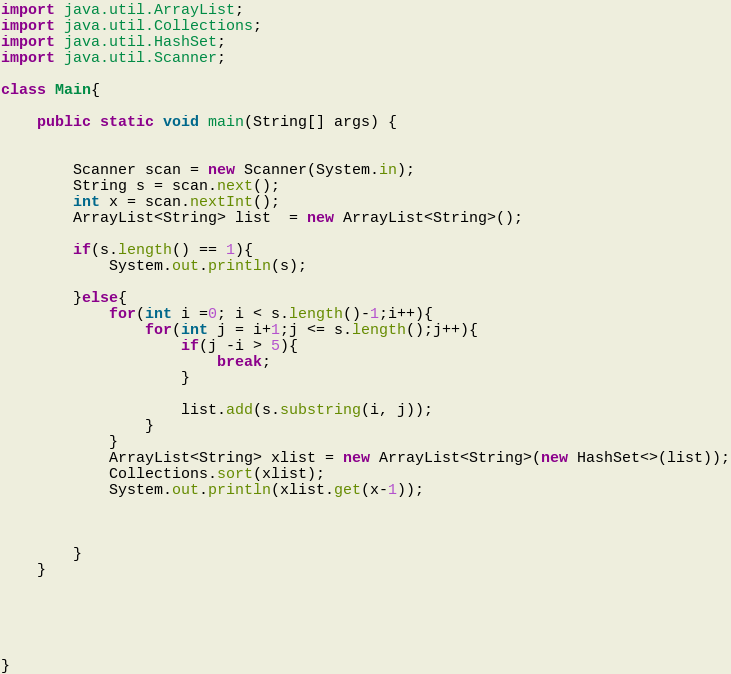<code> <loc_0><loc_0><loc_500><loc_500><_Java_>import java.util.ArrayList;
import java.util.Collections;
import java.util.HashSet;
import java.util.Scanner;

class Main{

	public static void main(String[] args) {


		Scanner scan = new Scanner(System.in);
		String s = scan.next();
		int x = scan.nextInt();
		ArrayList<String> list  = new ArrayList<String>();

		if(s.length() == 1){
			System.out.println(s);

		}else{
			for(int i =0; i < s.length()-1;i++){
				for(int j = i+1;j <= s.length();j++){
					if(j -i > 5){
						break;	
					}
					
					list.add(s.substring(i, j));
				}
			}
			ArrayList<String> xlist = new ArrayList<String>(new HashSet<>(list));
			Collections.sort(xlist);
			System.out.println(xlist.get(x-1));



		}
	}





}




</code> 